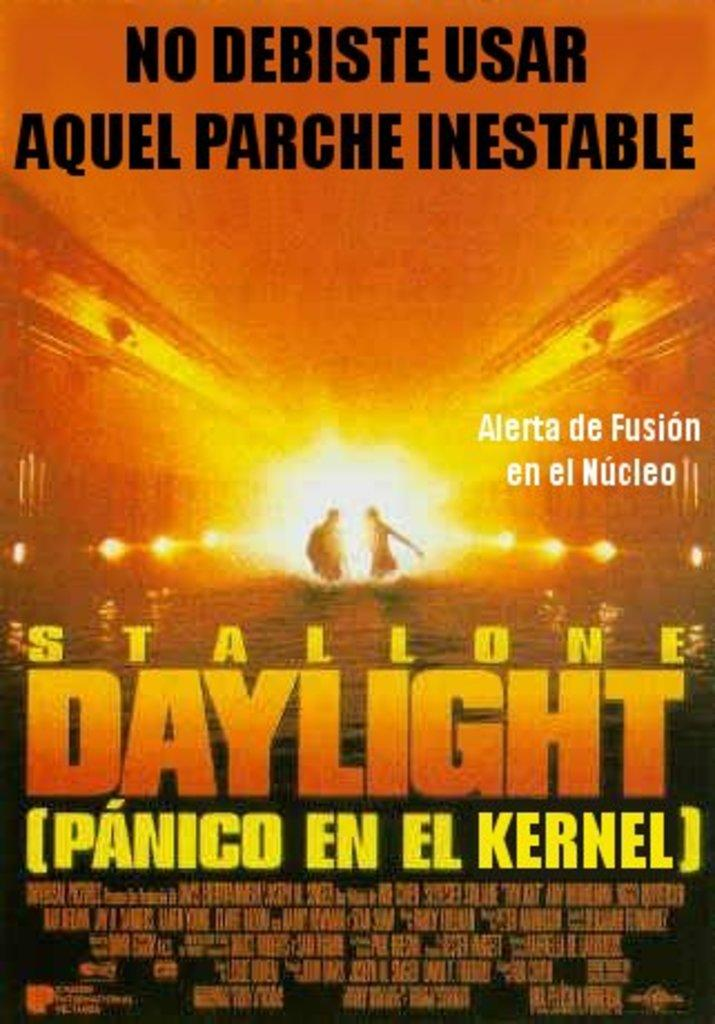<image>
Give a short and clear explanation of the subsequent image. Poster for Stallione Daylight showing two people in a bright light. 